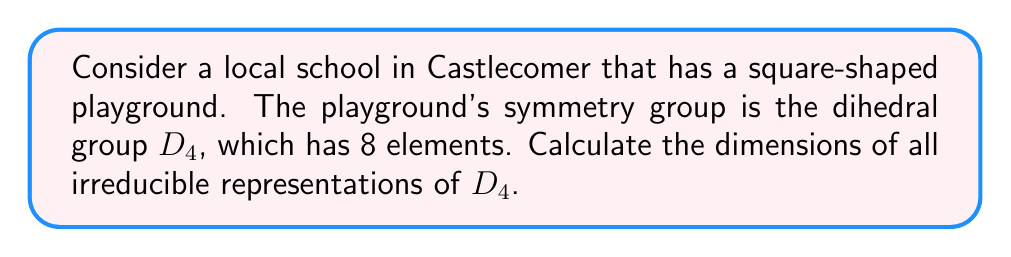Can you answer this question? To find the dimensions of irreducible representations for $D_4$, we'll follow these steps:

1) First, recall the formula for the sum of squares of dimensions of irreducible representations:

   $$\sum_{i=1}^{k} d_i^2 = |G|$$

   Where $d_i$ are the dimensions of irreducible representations and $|G|$ is the order of the group.

2) For $D_4$, we know $|G| = 8$.

3) $D_4$ is a non-abelian group, so it will have some 1-dimensional and some 2-dimensional irreducible representations.

4) For any group, the number of 1-dimensional irreducible representations is equal to the number of conjugacy classes of the group. $D_4$ has 5 conjugacy classes.

5) Let's say there are $x$ 2-dimensional irreducible representations. Then we can write:

   $$5 \cdot 1^2 + x \cdot 2^2 = 8$$

6) Simplifying:

   $$5 + 4x = 8$$
   $$4x = 3$$
   $$x = \frac{3}{4}$$

7) Since $x$ must be an integer, the only solution is $x = 1$.

Therefore, $D_4$ has five 1-dimensional irreducible representations and one 2-dimensional irreducible representation.
Answer: Five 1-dimensional and one 2-dimensional irreducible representations 